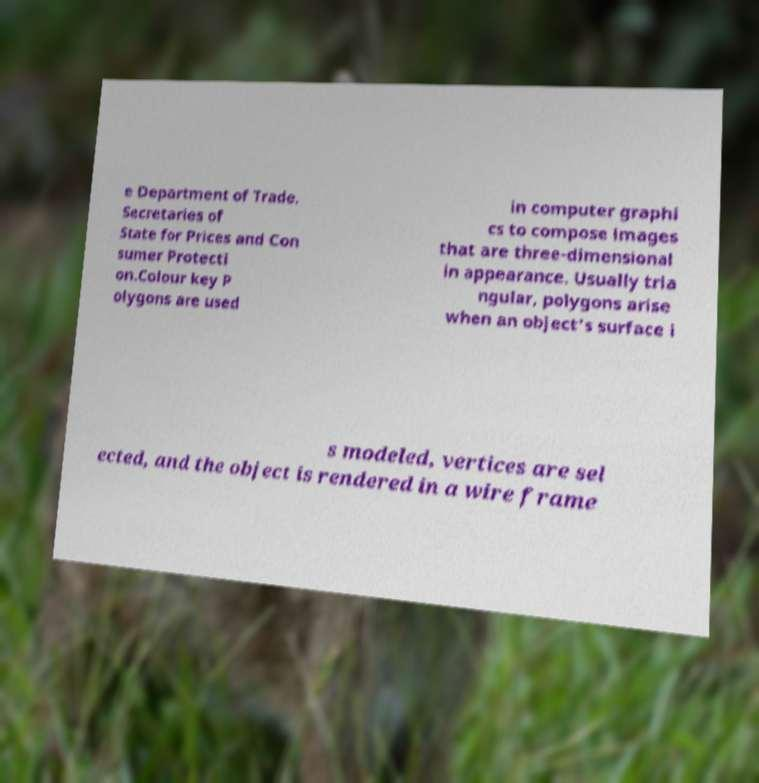I need the written content from this picture converted into text. Can you do that? e Department of Trade. Secretaries of State for Prices and Con sumer Protecti on.Colour key P olygons are used in computer graphi cs to compose images that are three-dimensional in appearance. Usually tria ngular, polygons arise when an object's surface i s modeled, vertices are sel ected, and the object is rendered in a wire frame 